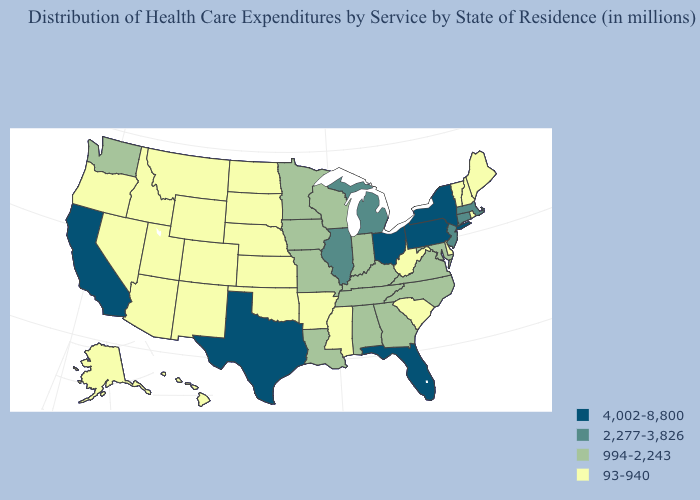What is the lowest value in the USA?
Concise answer only. 93-940. What is the highest value in the USA?
Be succinct. 4,002-8,800. Does Delaware have the lowest value in the South?
Concise answer only. Yes. What is the highest value in states that border Vermont?
Short answer required. 4,002-8,800. Name the states that have a value in the range 93-940?
Quick response, please. Alaska, Arizona, Arkansas, Colorado, Delaware, Hawaii, Idaho, Kansas, Maine, Mississippi, Montana, Nebraska, Nevada, New Hampshire, New Mexico, North Dakota, Oklahoma, Oregon, Rhode Island, South Carolina, South Dakota, Utah, Vermont, West Virginia, Wyoming. Name the states that have a value in the range 4,002-8,800?
Quick response, please. California, Florida, New York, Ohio, Pennsylvania, Texas. What is the lowest value in the South?
Quick response, please. 93-940. Which states have the lowest value in the Northeast?
Answer briefly. Maine, New Hampshire, Rhode Island, Vermont. Does Vermont have a lower value than Nevada?
Keep it brief. No. What is the lowest value in the South?
Give a very brief answer. 93-940. Does Kansas have the lowest value in the USA?
Answer briefly. Yes. What is the highest value in the MidWest ?
Short answer required. 4,002-8,800. Name the states that have a value in the range 4,002-8,800?
Keep it brief. California, Florida, New York, Ohio, Pennsylvania, Texas. What is the highest value in states that border Connecticut?
Short answer required. 4,002-8,800. 